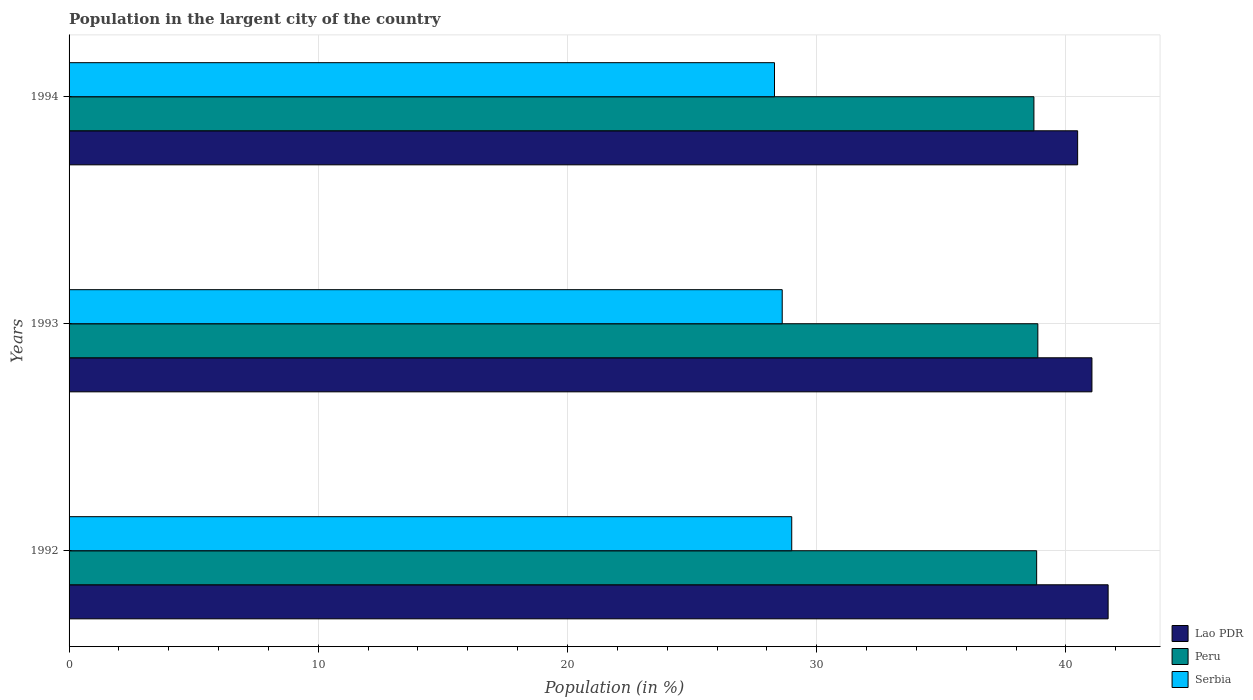How many different coloured bars are there?
Offer a very short reply. 3. Are the number of bars per tick equal to the number of legend labels?
Give a very brief answer. Yes. How many bars are there on the 2nd tick from the top?
Offer a terse response. 3. In how many cases, is the number of bars for a given year not equal to the number of legend labels?
Give a very brief answer. 0. What is the percentage of population in the largent city in Peru in 1992?
Offer a very short reply. 38.82. Across all years, what is the maximum percentage of population in the largent city in Peru?
Make the answer very short. 38.87. Across all years, what is the minimum percentage of population in the largent city in Lao PDR?
Your answer should be compact. 40.47. In which year was the percentage of population in the largent city in Serbia maximum?
Your answer should be compact. 1992. What is the total percentage of population in the largent city in Lao PDR in the graph?
Keep it short and to the point. 123.2. What is the difference between the percentage of population in the largent city in Lao PDR in 1992 and that in 1994?
Give a very brief answer. 1.22. What is the difference between the percentage of population in the largent city in Lao PDR in 1992 and the percentage of population in the largent city in Peru in 1993?
Provide a succinct answer. 2.82. What is the average percentage of population in the largent city in Peru per year?
Give a very brief answer. 38.8. In the year 1992, what is the difference between the percentage of population in the largent city in Lao PDR and percentage of population in the largent city in Serbia?
Ensure brevity in your answer.  12.7. In how many years, is the percentage of population in the largent city in Serbia greater than 16 %?
Ensure brevity in your answer.  3. What is the ratio of the percentage of population in the largent city in Lao PDR in 1992 to that in 1994?
Ensure brevity in your answer.  1.03. Is the percentage of population in the largent city in Serbia in 1993 less than that in 1994?
Your response must be concise. No. What is the difference between the highest and the second highest percentage of population in the largent city in Lao PDR?
Ensure brevity in your answer.  0.65. What is the difference between the highest and the lowest percentage of population in the largent city in Serbia?
Make the answer very short. 0.69. Is the sum of the percentage of population in the largent city in Lao PDR in 1993 and 1994 greater than the maximum percentage of population in the largent city in Serbia across all years?
Provide a succinct answer. Yes. What does the 1st bar from the top in 1994 represents?
Give a very brief answer. Serbia. What does the 3rd bar from the bottom in 1992 represents?
Give a very brief answer. Serbia. How many bars are there?
Provide a succinct answer. 9. Are all the bars in the graph horizontal?
Offer a very short reply. Yes. How many years are there in the graph?
Provide a succinct answer. 3. Does the graph contain any zero values?
Ensure brevity in your answer.  No. Does the graph contain grids?
Your answer should be compact. Yes. Where does the legend appear in the graph?
Your answer should be compact. Bottom right. What is the title of the graph?
Give a very brief answer. Population in the largent city of the country. What is the label or title of the X-axis?
Your answer should be compact. Population (in %). What is the label or title of the Y-axis?
Keep it short and to the point. Years. What is the Population (in %) of Lao PDR in 1992?
Keep it short and to the point. 41.69. What is the Population (in %) in Peru in 1992?
Keep it short and to the point. 38.82. What is the Population (in %) in Serbia in 1992?
Offer a terse response. 29. What is the Population (in %) of Lao PDR in 1993?
Provide a succinct answer. 41.04. What is the Population (in %) of Peru in 1993?
Offer a terse response. 38.87. What is the Population (in %) in Serbia in 1993?
Offer a very short reply. 28.62. What is the Population (in %) in Lao PDR in 1994?
Provide a succinct answer. 40.47. What is the Population (in %) in Peru in 1994?
Offer a very short reply. 38.71. What is the Population (in %) of Serbia in 1994?
Your answer should be very brief. 28.31. Across all years, what is the maximum Population (in %) of Lao PDR?
Offer a terse response. 41.69. Across all years, what is the maximum Population (in %) in Peru?
Provide a succinct answer. 38.87. Across all years, what is the maximum Population (in %) of Serbia?
Your response must be concise. 29. Across all years, what is the minimum Population (in %) in Lao PDR?
Your response must be concise. 40.47. Across all years, what is the minimum Population (in %) of Peru?
Make the answer very short. 38.71. Across all years, what is the minimum Population (in %) in Serbia?
Your answer should be very brief. 28.31. What is the total Population (in %) in Lao PDR in the graph?
Keep it short and to the point. 123.2. What is the total Population (in %) of Peru in the graph?
Your response must be concise. 116.41. What is the total Population (in %) in Serbia in the graph?
Your answer should be compact. 85.92. What is the difference between the Population (in %) of Lao PDR in 1992 and that in 1993?
Provide a succinct answer. 0.65. What is the difference between the Population (in %) in Peru in 1992 and that in 1993?
Ensure brevity in your answer.  -0.05. What is the difference between the Population (in %) of Serbia in 1992 and that in 1993?
Your answer should be very brief. 0.38. What is the difference between the Population (in %) of Lao PDR in 1992 and that in 1994?
Ensure brevity in your answer.  1.22. What is the difference between the Population (in %) in Peru in 1992 and that in 1994?
Your answer should be compact. 0.11. What is the difference between the Population (in %) in Serbia in 1992 and that in 1994?
Ensure brevity in your answer.  0.69. What is the difference between the Population (in %) of Lao PDR in 1993 and that in 1994?
Offer a terse response. 0.57. What is the difference between the Population (in %) of Peru in 1993 and that in 1994?
Provide a short and direct response. 0.16. What is the difference between the Population (in %) in Serbia in 1993 and that in 1994?
Make the answer very short. 0.31. What is the difference between the Population (in %) in Lao PDR in 1992 and the Population (in %) in Peru in 1993?
Provide a succinct answer. 2.82. What is the difference between the Population (in %) in Lao PDR in 1992 and the Population (in %) in Serbia in 1993?
Your response must be concise. 13.08. What is the difference between the Population (in %) of Peru in 1992 and the Population (in %) of Serbia in 1993?
Keep it short and to the point. 10.21. What is the difference between the Population (in %) of Lao PDR in 1992 and the Population (in %) of Peru in 1994?
Your response must be concise. 2.98. What is the difference between the Population (in %) in Lao PDR in 1992 and the Population (in %) in Serbia in 1994?
Offer a very short reply. 13.39. What is the difference between the Population (in %) in Peru in 1992 and the Population (in %) in Serbia in 1994?
Offer a very short reply. 10.52. What is the difference between the Population (in %) of Lao PDR in 1993 and the Population (in %) of Peru in 1994?
Offer a terse response. 2.33. What is the difference between the Population (in %) of Lao PDR in 1993 and the Population (in %) of Serbia in 1994?
Offer a terse response. 12.74. What is the difference between the Population (in %) of Peru in 1993 and the Population (in %) of Serbia in 1994?
Keep it short and to the point. 10.57. What is the average Population (in %) in Lao PDR per year?
Offer a very short reply. 41.07. What is the average Population (in %) in Peru per year?
Keep it short and to the point. 38.8. What is the average Population (in %) in Serbia per year?
Ensure brevity in your answer.  28.64. In the year 1992, what is the difference between the Population (in %) of Lao PDR and Population (in %) of Peru?
Ensure brevity in your answer.  2.87. In the year 1992, what is the difference between the Population (in %) in Lao PDR and Population (in %) in Serbia?
Offer a terse response. 12.7. In the year 1992, what is the difference between the Population (in %) of Peru and Population (in %) of Serbia?
Your answer should be compact. 9.83. In the year 1993, what is the difference between the Population (in %) in Lao PDR and Population (in %) in Peru?
Offer a very short reply. 2.17. In the year 1993, what is the difference between the Population (in %) of Lao PDR and Population (in %) of Serbia?
Offer a terse response. 12.43. In the year 1993, what is the difference between the Population (in %) in Peru and Population (in %) in Serbia?
Give a very brief answer. 10.26. In the year 1994, what is the difference between the Population (in %) in Lao PDR and Population (in %) in Peru?
Ensure brevity in your answer.  1.75. In the year 1994, what is the difference between the Population (in %) in Lao PDR and Population (in %) in Serbia?
Offer a very short reply. 12.16. In the year 1994, what is the difference between the Population (in %) of Peru and Population (in %) of Serbia?
Provide a succinct answer. 10.41. What is the ratio of the Population (in %) of Lao PDR in 1992 to that in 1993?
Provide a succinct answer. 1.02. What is the ratio of the Population (in %) in Peru in 1992 to that in 1993?
Provide a succinct answer. 1. What is the ratio of the Population (in %) in Serbia in 1992 to that in 1993?
Keep it short and to the point. 1.01. What is the ratio of the Population (in %) in Lao PDR in 1992 to that in 1994?
Offer a terse response. 1.03. What is the ratio of the Population (in %) of Serbia in 1992 to that in 1994?
Your answer should be compact. 1.02. What is the ratio of the Population (in %) of Lao PDR in 1993 to that in 1994?
Your answer should be very brief. 1.01. What is the ratio of the Population (in %) in Peru in 1993 to that in 1994?
Your response must be concise. 1. What is the ratio of the Population (in %) in Serbia in 1993 to that in 1994?
Provide a succinct answer. 1.01. What is the difference between the highest and the second highest Population (in %) of Lao PDR?
Keep it short and to the point. 0.65. What is the difference between the highest and the second highest Population (in %) in Peru?
Your answer should be very brief. 0.05. What is the difference between the highest and the second highest Population (in %) of Serbia?
Give a very brief answer. 0.38. What is the difference between the highest and the lowest Population (in %) of Lao PDR?
Your answer should be compact. 1.22. What is the difference between the highest and the lowest Population (in %) in Peru?
Provide a succinct answer. 0.16. What is the difference between the highest and the lowest Population (in %) in Serbia?
Keep it short and to the point. 0.69. 